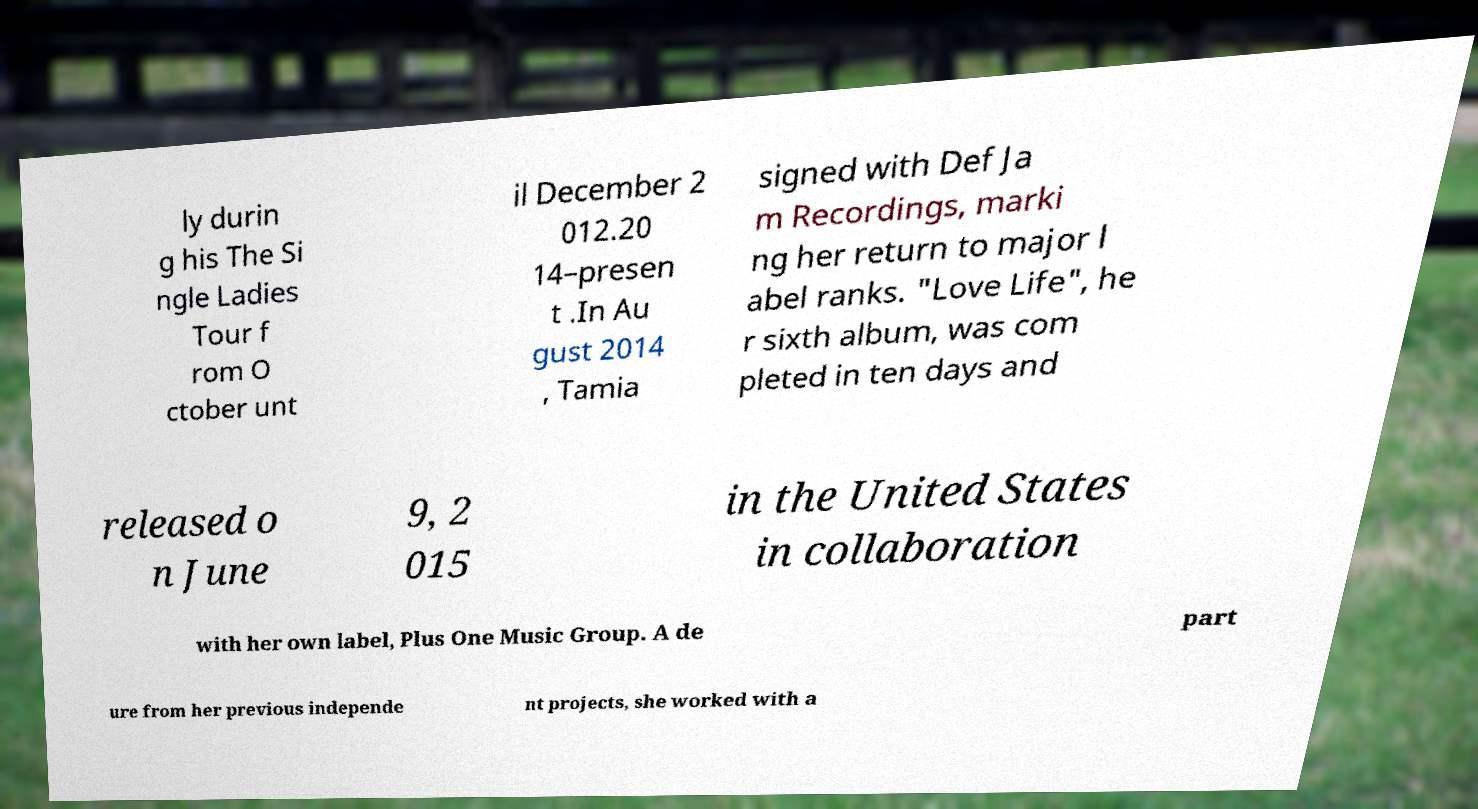Could you extract and type out the text from this image? ly durin g his The Si ngle Ladies Tour f rom O ctober unt il December 2 012.20 14–presen t .In Au gust 2014 , Tamia signed with Def Ja m Recordings, marki ng her return to major l abel ranks. "Love Life", he r sixth album, was com pleted in ten days and released o n June 9, 2 015 in the United States in collaboration with her own label, Plus One Music Group. A de part ure from her previous independe nt projects, she worked with a 